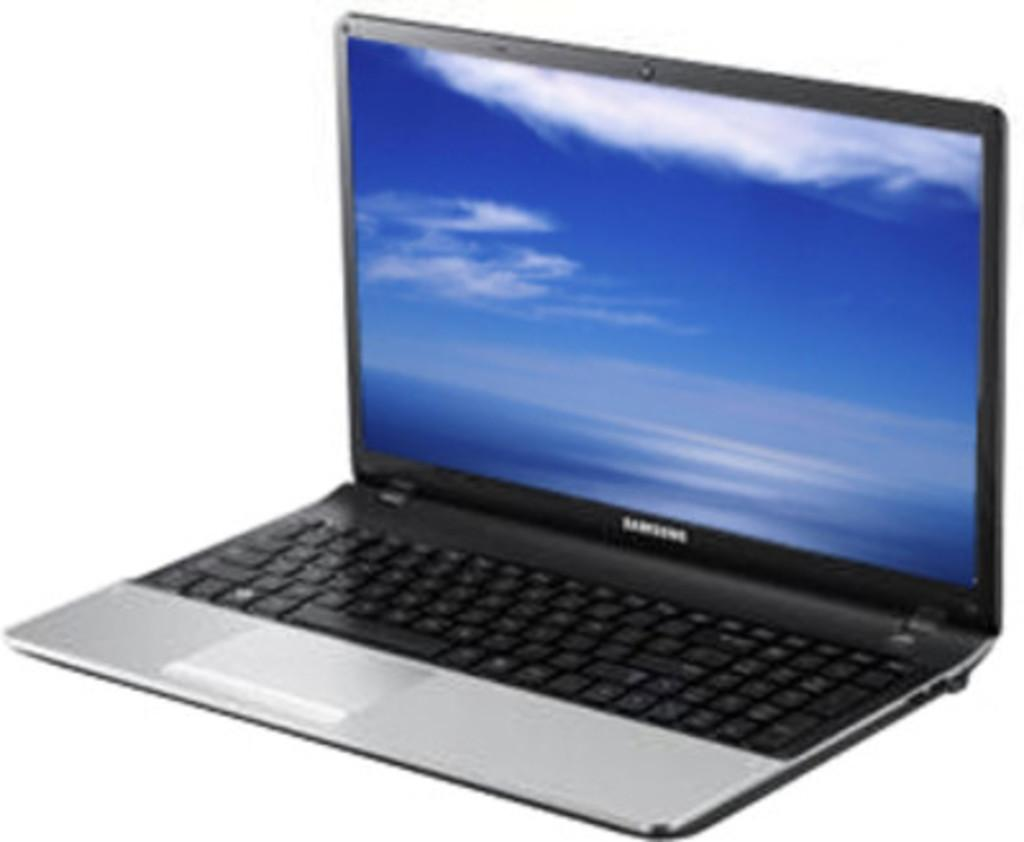Provide a one-sentence caption for the provided image. A Samsung laptop sits with the screen saver on. 